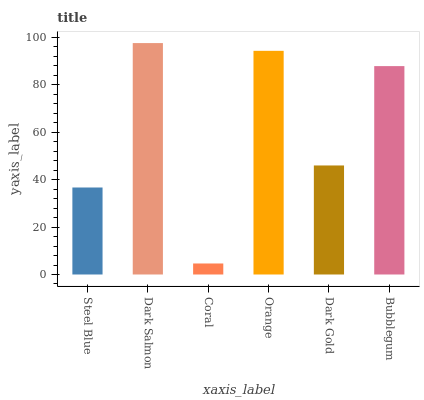Is Coral the minimum?
Answer yes or no. Yes. Is Dark Salmon the maximum?
Answer yes or no. Yes. Is Dark Salmon the minimum?
Answer yes or no. No. Is Coral the maximum?
Answer yes or no. No. Is Dark Salmon greater than Coral?
Answer yes or no. Yes. Is Coral less than Dark Salmon?
Answer yes or no. Yes. Is Coral greater than Dark Salmon?
Answer yes or no. No. Is Dark Salmon less than Coral?
Answer yes or no. No. Is Bubblegum the high median?
Answer yes or no. Yes. Is Dark Gold the low median?
Answer yes or no. Yes. Is Dark Gold the high median?
Answer yes or no. No. Is Steel Blue the low median?
Answer yes or no. No. 